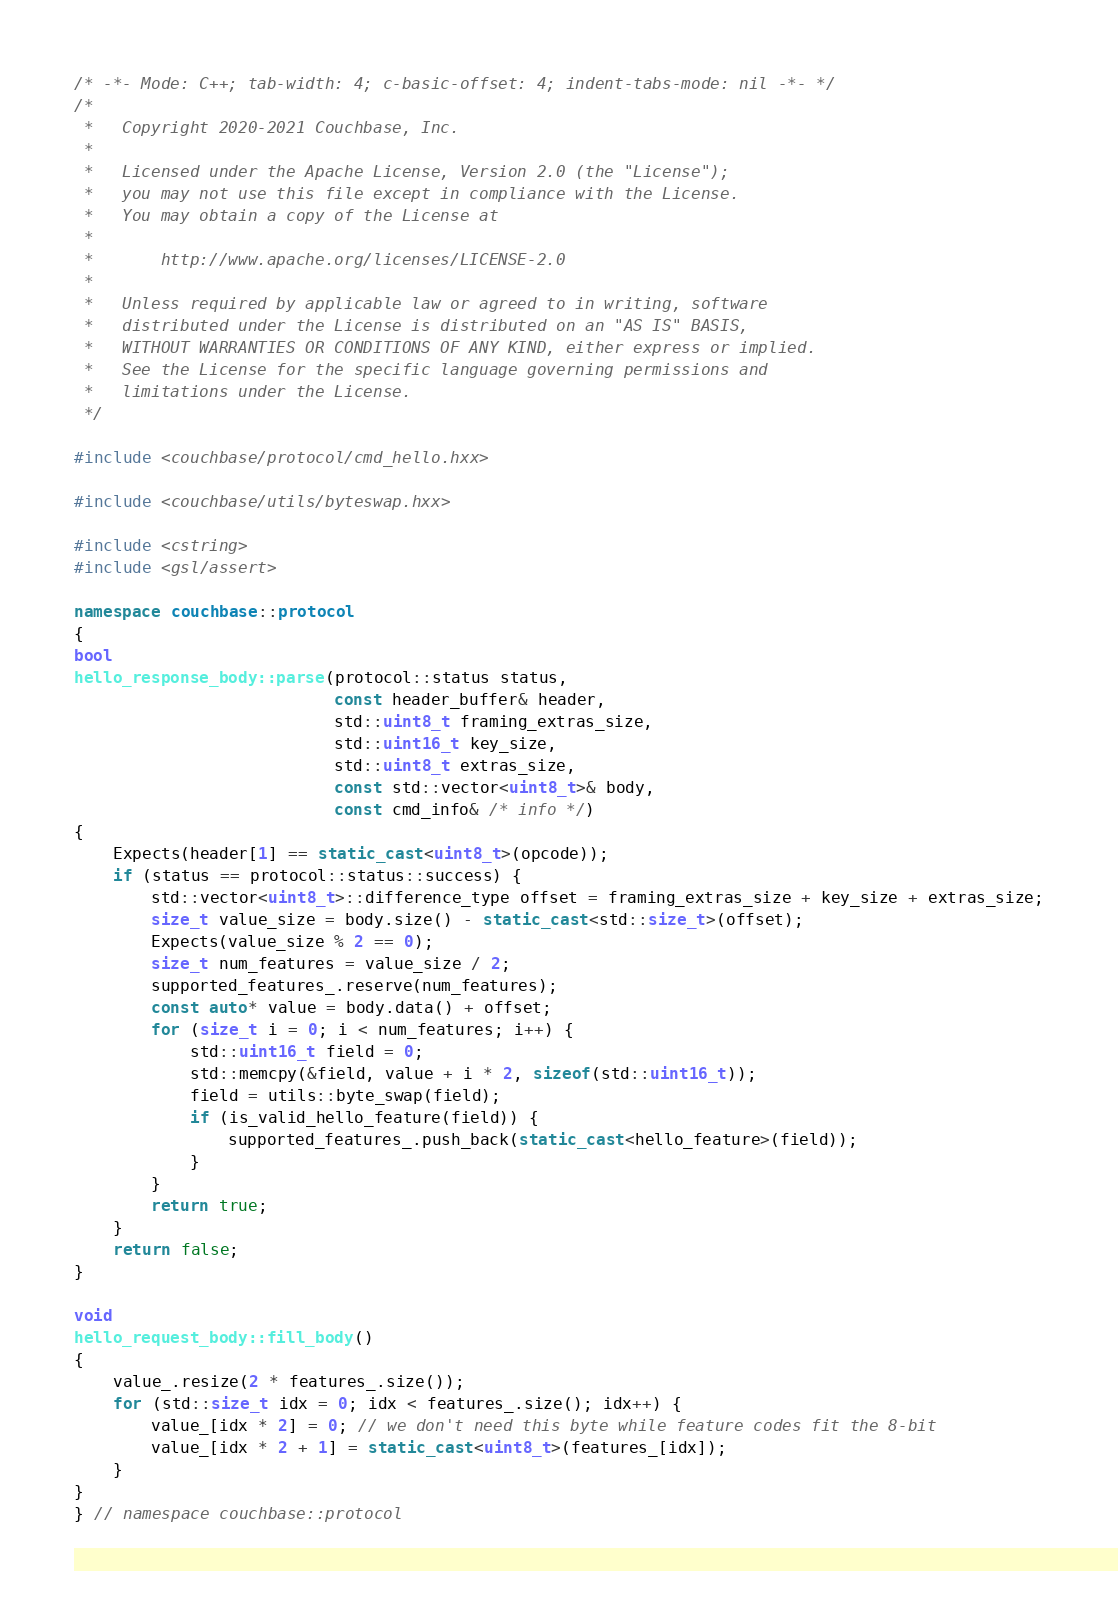<code> <loc_0><loc_0><loc_500><loc_500><_C++_>/* -*- Mode: C++; tab-width: 4; c-basic-offset: 4; indent-tabs-mode: nil -*- */
/*
 *   Copyright 2020-2021 Couchbase, Inc.
 *
 *   Licensed under the Apache License, Version 2.0 (the "License");
 *   you may not use this file except in compliance with the License.
 *   You may obtain a copy of the License at
 *
 *       http://www.apache.org/licenses/LICENSE-2.0
 *
 *   Unless required by applicable law or agreed to in writing, software
 *   distributed under the License is distributed on an "AS IS" BASIS,
 *   WITHOUT WARRANTIES OR CONDITIONS OF ANY KIND, either express or implied.
 *   See the License for the specific language governing permissions and
 *   limitations under the License.
 */

#include <couchbase/protocol/cmd_hello.hxx>

#include <couchbase/utils/byteswap.hxx>

#include <cstring>
#include <gsl/assert>

namespace couchbase::protocol
{
bool
hello_response_body::parse(protocol::status status,
                           const header_buffer& header,
                           std::uint8_t framing_extras_size,
                           std::uint16_t key_size,
                           std::uint8_t extras_size,
                           const std::vector<uint8_t>& body,
                           const cmd_info& /* info */)
{
    Expects(header[1] == static_cast<uint8_t>(opcode));
    if (status == protocol::status::success) {
        std::vector<uint8_t>::difference_type offset = framing_extras_size + key_size + extras_size;
        size_t value_size = body.size() - static_cast<std::size_t>(offset);
        Expects(value_size % 2 == 0);
        size_t num_features = value_size / 2;
        supported_features_.reserve(num_features);
        const auto* value = body.data() + offset;
        for (size_t i = 0; i < num_features; i++) {
            std::uint16_t field = 0;
            std::memcpy(&field, value + i * 2, sizeof(std::uint16_t));
            field = utils::byte_swap(field);
            if (is_valid_hello_feature(field)) {
                supported_features_.push_back(static_cast<hello_feature>(field));
            }
        }
        return true;
    }
    return false;
}

void
hello_request_body::fill_body()
{
    value_.resize(2 * features_.size());
    for (std::size_t idx = 0; idx < features_.size(); idx++) {
        value_[idx * 2] = 0; // we don't need this byte while feature codes fit the 8-bit
        value_[idx * 2 + 1] = static_cast<uint8_t>(features_[idx]);
    }
}
} // namespace couchbase::protocol
</code> 